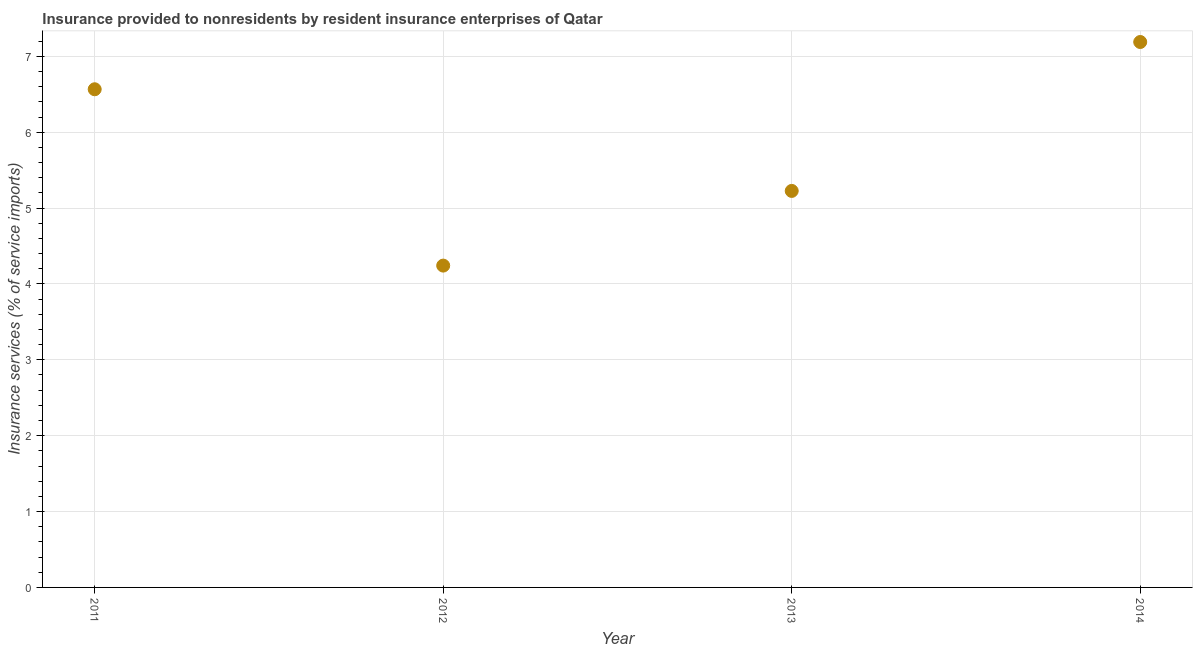What is the insurance and financial services in 2014?
Your answer should be very brief. 7.19. Across all years, what is the maximum insurance and financial services?
Provide a succinct answer. 7.19. Across all years, what is the minimum insurance and financial services?
Make the answer very short. 4.24. In which year was the insurance and financial services minimum?
Offer a very short reply. 2012. What is the sum of the insurance and financial services?
Your answer should be compact. 23.22. What is the difference between the insurance and financial services in 2011 and 2012?
Your answer should be very brief. 2.32. What is the average insurance and financial services per year?
Make the answer very short. 5.81. What is the median insurance and financial services?
Provide a short and direct response. 5.9. In how many years, is the insurance and financial services greater than 0.2 %?
Make the answer very short. 4. What is the ratio of the insurance and financial services in 2012 to that in 2013?
Your response must be concise. 0.81. Is the difference between the insurance and financial services in 2012 and 2013 greater than the difference between any two years?
Your answer should be compact. No. What is the difference between the highest and the second highest insurance and financial services?
Make the answer very short. 0.62. Is the sum of the insurance and financial services in 2012 and 2013 greater than the maximum insurance and financial services across all years?
Your answer should be very brief. Yes. What is the difference between the highest and the lowest insurance and financial services?
Keep it short and to the point. 2.95. In how many years, is the insurance and financial services greater than the average insurance and financial services taken over all years?
Offer a very short reply. 2. Does the graph contain grids?
Provide a short and direct response. Yes. What is the title of the graph?
Give a very brief answer. Insurance provided to nonresidents by resident insurance enterprises of Qatar. What is the label or title of the Y-axis?
Give a very brief answer. Insurance services (% of service imports). What is the Insurance services (% of service imports) in 2011?
Provide a short and direct response. 6.57. What is the Insurance services (% of service imports) in 2012?
Your answer should be compact. 4.24. What is the Insurance services (% of service imports) in 2013?
Give a very brief answer. 5.23. What is the Insurance services (% of service imports) in 2014?
Offer a very short reply. 7.19. What is the difference between the Insurance services (% of service imports) in 2011 and 2012?
Your answer should be compact. 2.32. What is the difference between the Insurance services (% of service imports) in 2011 and 2013?
Your answer should be very brief. 1.34. What is the difference between the Insurance services (% of service imports) in 2011 and 2014?
Offer a very short reply. -0.62. What is the difference between the Insurance services (% of service imports) in 2012 and 2013?
Give a very brief answer. -0.98. What is the difference between the Insurance services (% of service imports) in 2012 and 2014?
Your answer should be compact. -2.95. What is the difference between the Insurance services (% of service imports) in 2013 and 2014?
Your answer should be compact. -1.96. What is the ratio of the Insurance services (% of service imports) in 2011 to that in 2012?
Offer a terse response. 1.55. What is the ratio of the Insurance services (% of service imports) in 2011 to that in 2013?
Ensure brevity in your answer.  1.26. What is the ratio of the Insurance services (% of service imports) in 2012 to that in 2013?
Keep it short and to the point. 0.81. What is the ratio of the Insurance services (% of service imports) in 2012 to that in 2014?
Give a very brief answer. 0.59. What is the ratio of the Insurance services (% of service imports) in 2013 to that in 2014?
Your answer should be compact. 0.73. 